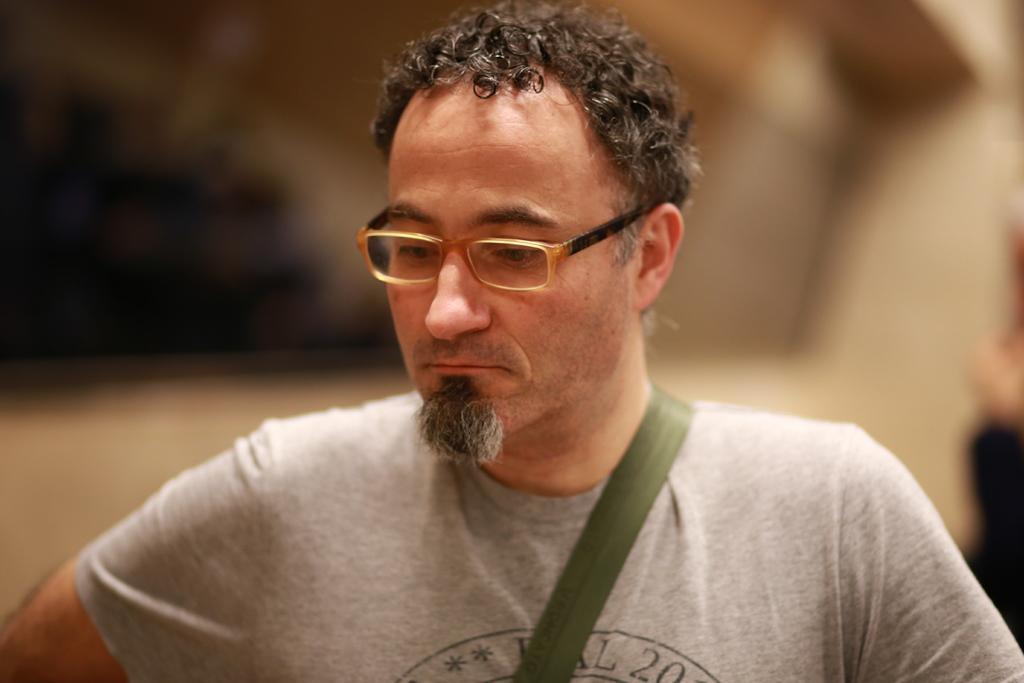Describe this image in one or two sentences. In this image I can see a man wearing spectacles. The background is blurred. 